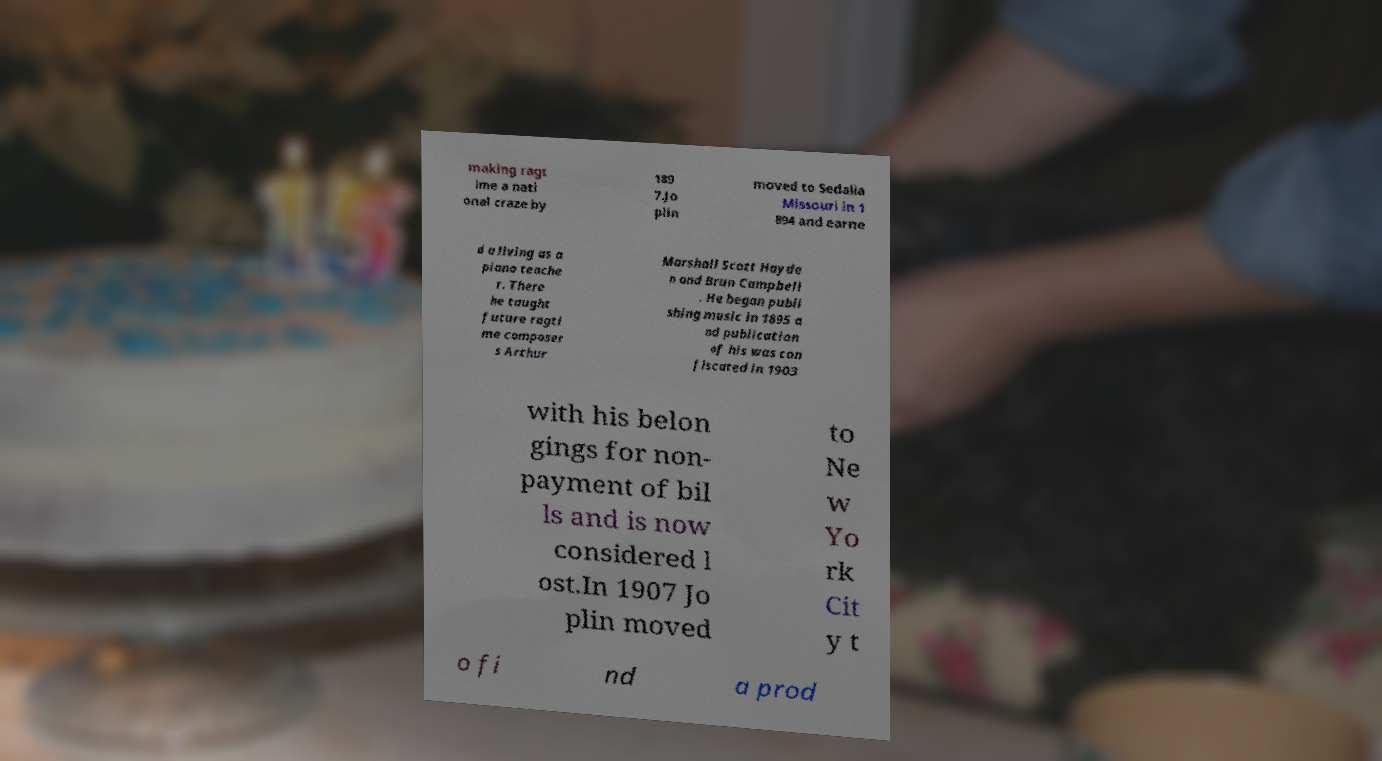Could you assist in decoding the text presented in this image and type it out clearly? making ragt ime a nati onal craze by 189 7.Jo plin moved to Sedalia Missouri in 1 894 and earne d a living as a piano teache r. There he taught future ragti me composer s Arthur Marshall Scott Hayde n and Brun Campbell . He began publi shing music in 1895 a nd publication of his was con fiscated in 1903 with his belon gings for non- payment of bil ls and is now considered l ost.In 1907 Jo plin moved to Ne w Yo rk Cit y t o fi nd a prod 